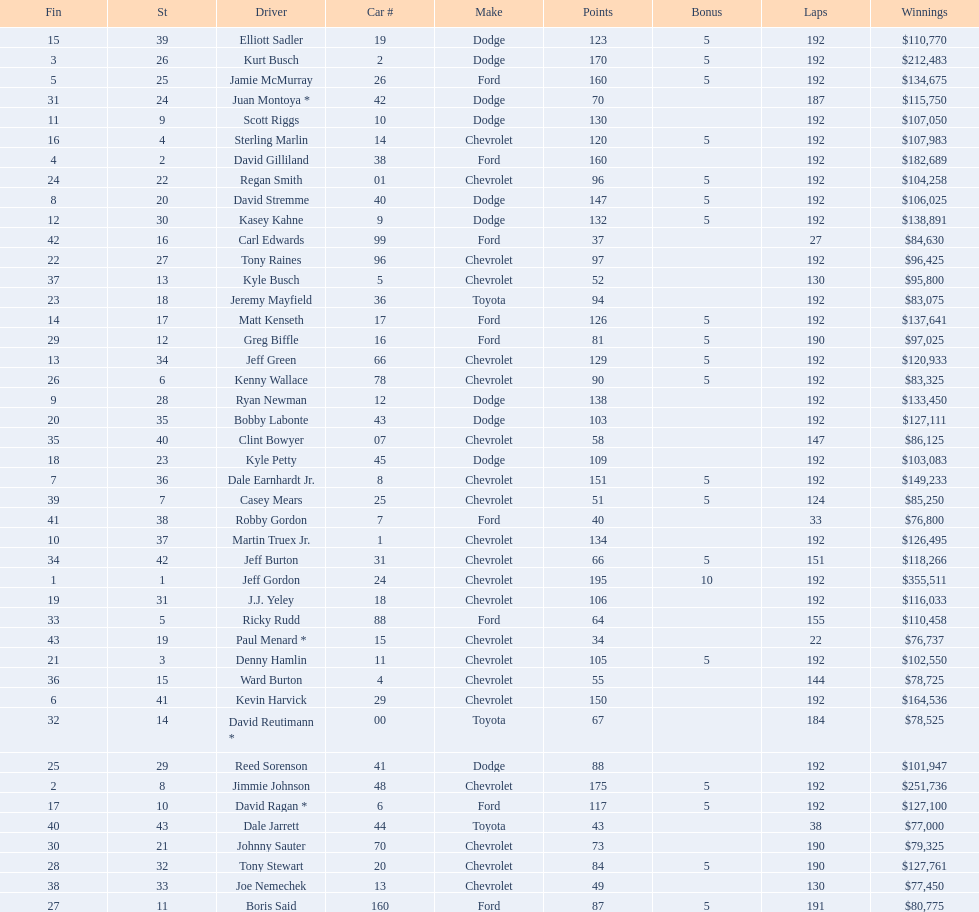How many drivers placed below tony stewart? 15. 